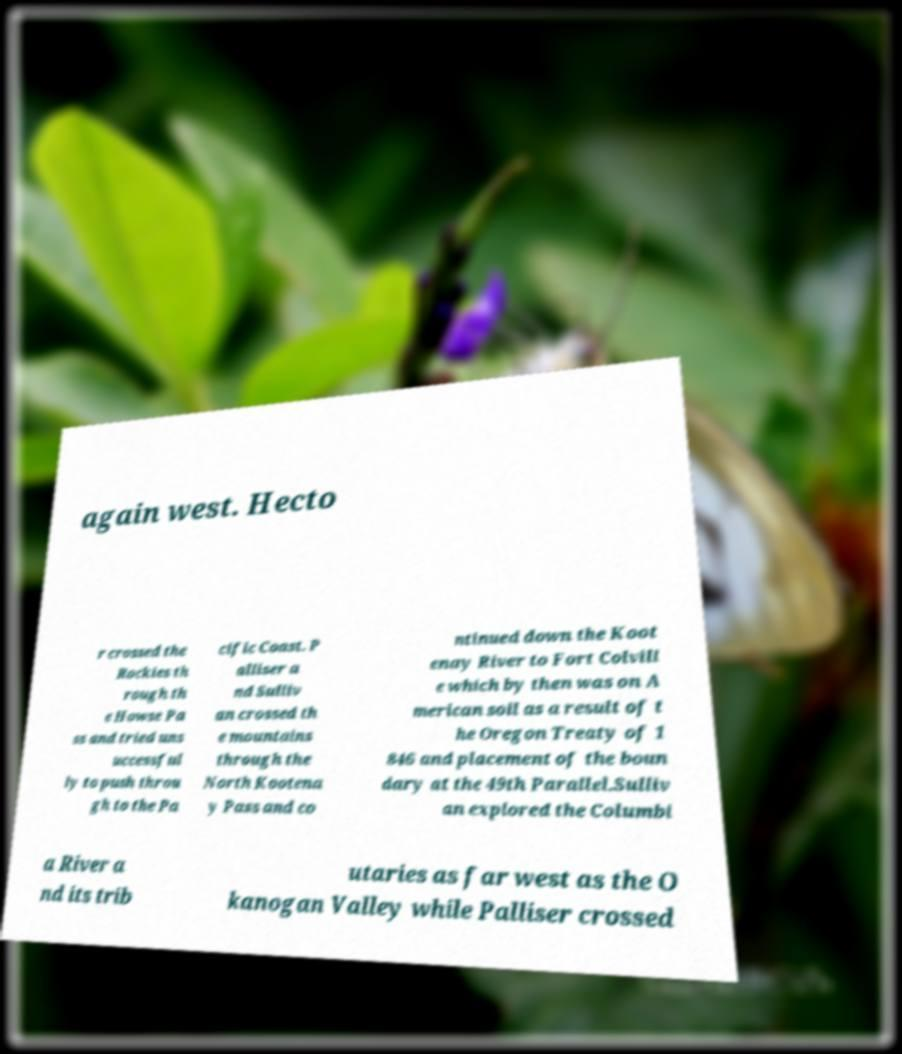I need the written content from this picture converted into text. Can you do that? again west. Hecto r crossed the Rockies th rough th e Howse Pa ss and tried uns uccessful ly to push throu gh to the Pa cific Coast. P alliser a nd Sulliv an crossed th e mountains through the North Kootena y Pass and co ntinued down the Koot enay River to Fort Colvill e which by then was on A merican soil as a result of t he Oregon Treaty of 1 846 and placement of the boun dary at the 49th Parallel.Sulliv an explored the Columbi a River a nd its trib utaries as far west as the O kanogan Valley while Palliser crossed 